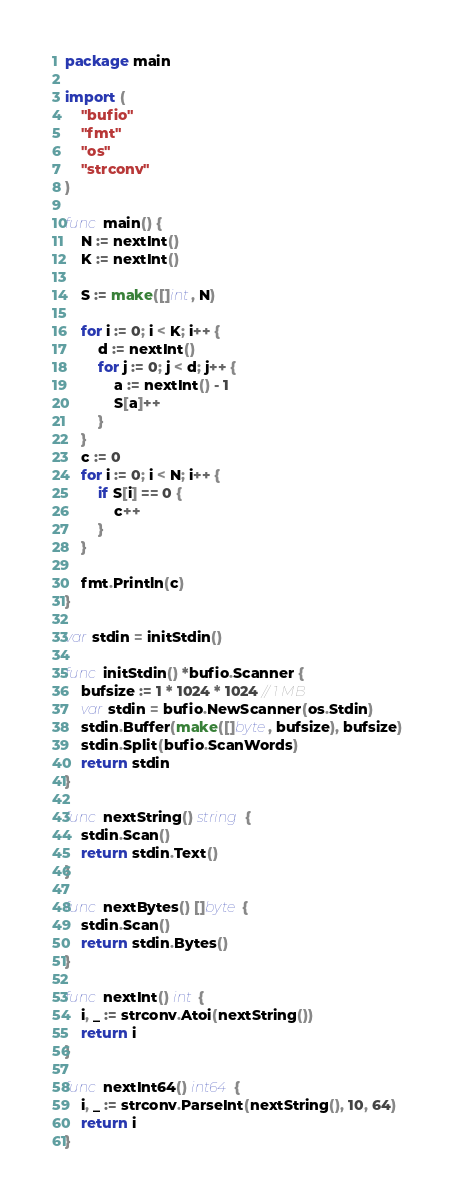<code> <loc_0><loc_0><loc_500><loc_500><_Go_>package main

import (
	"bufio"
	"fmt"
	"os"
	"strconv"
)

func main() {
	N := nextInt()
	K := nextInt()

	S := make([]int, N)

	for i := 0; i < K; i++ {
		d := nextInt()
		for j := 0; j < d; j++ {
			a := nextInt() - 1
			S[a]++
		}
	}
	c := 0
	for i := 0; i < N; i++ {
		if S[i] == 0 {
			c++
		}
	}

	fmt.Println(c)
}

var stdin = initStdin()

func initStdin() *bufio.Scanner {
	bufsize := 1 * 1024 * 1024 // 1 MB
	var stdin = bufio.NewScanner(os.Stdin)
	stdin.Buffer(make([]byte, bufsize), bufsize)
	stdin.Split(bufio.ScanWords)
	return stdin
}

func nextString() string {
	stdin.Scan()
	return stdin.Text()
}

func nextBytes() []byte {
	stdin.Scan()
	return stdin.Bytes()
}

func nextInt() int {
	i, _ := strconv.Atoi(nextString())
	return i
}

func nextInt64() int64 {
	i, _ := strconv.ParseInt(nextString(), 10, 64)
	return i
}
</code> 